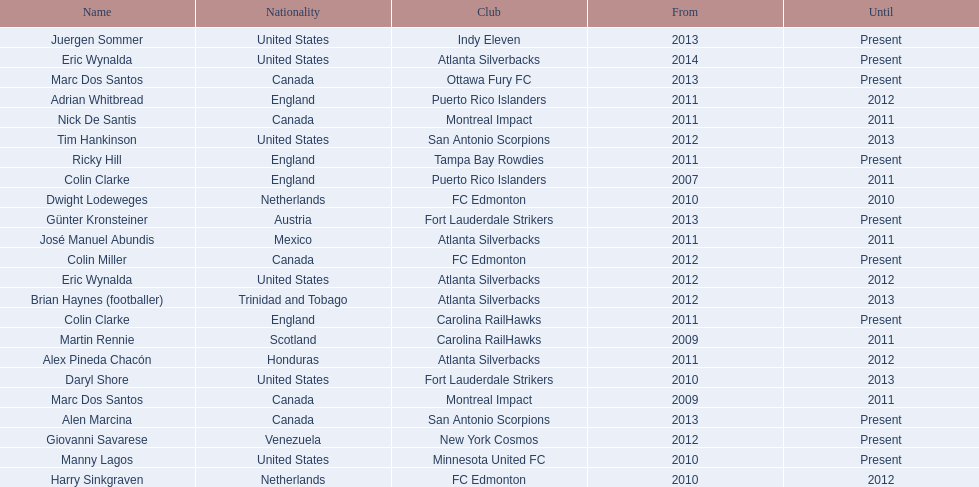How long did colin clarke coach the puerto rico islanders for? 4 years. 